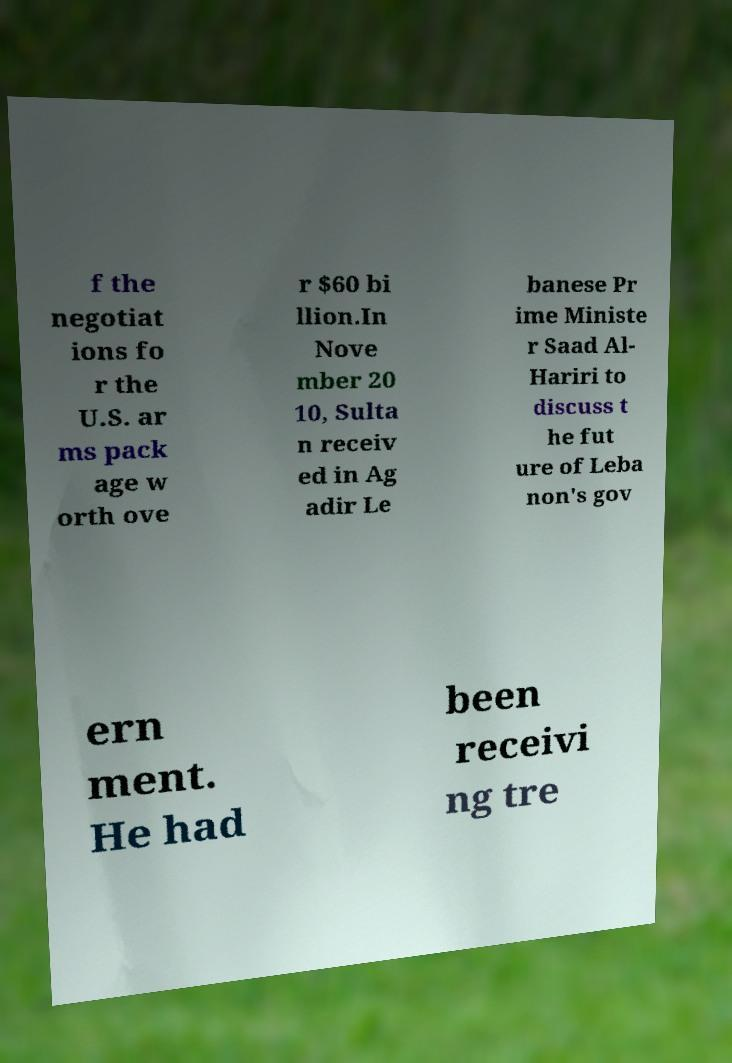Can you read and provide the text displayed in the image?This photo seems to have some interesting text. Can you extract and type it out for me? f the negotiat ions fo r the U.S. ar ms pack age w orth ove r $60 bi llion.In Nove mber 20 10, Sulta n receiv ed in Ag adir Le banese Pr ime Ministe r Saad Al- Hariri to discuss t he fut ure of Leba non's gov ern ment. He had been receivi ng tre 